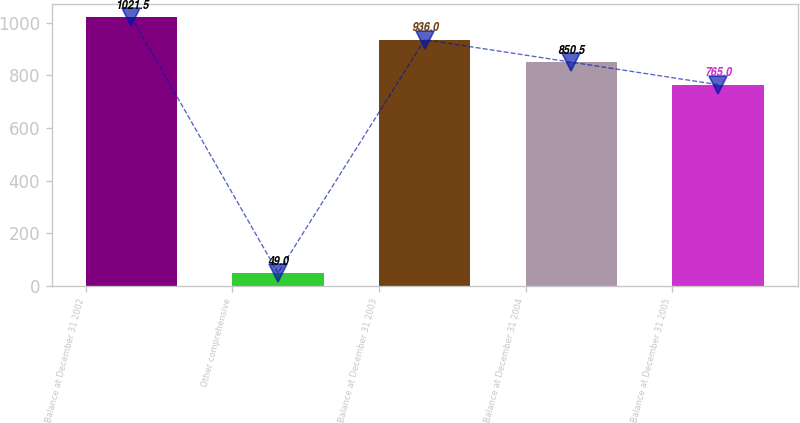Convert chart. <chart><loc_0><loc_0><loc_500><loc_500><bar_chart><fcel>Balance at December 31 2002<fcel>Other comprehensive<fcel>Balance at December 31 2003<fcel>Balance at December 31 2004<fcel>Balance at December 31 2005<nl><fcel>1021.5<fcel>49<fcel>936<fcel>850.5<fcel>765<nl></chart> 